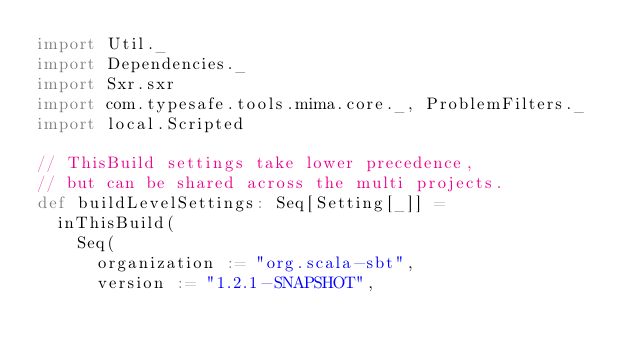<code> <loc_0><loc_0><loc_500><loc_500><_Scala_>import Util._
import Dependencies._
import Sxr.sxr
import com.typesafe.tools.mima.core._, ProblemFilters._
import local.Scripted

// ThisBuild settings take lower precedence,
// but can be shared across the multi projects.
def buildLevelSettings: Seq[Setting[_]] =
  inThisBuild(
    Seq(
      organization := "org.scala-sbt",
      version := "1.2.1-SNAPSHOT",</code> 